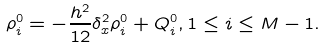<formula> <loc_0><loc_0><loc_500><loc_500>\rho _ { i } ^ { 0 } = - \frac { h ^ { 2 } } { 1 2 } \delta _ { x } ^ { 2 } \rho _ { i } ^ { 0 } + Q _ { i } ^ { 0 } , 1 \leq i \leq M - 1 .</formula> 